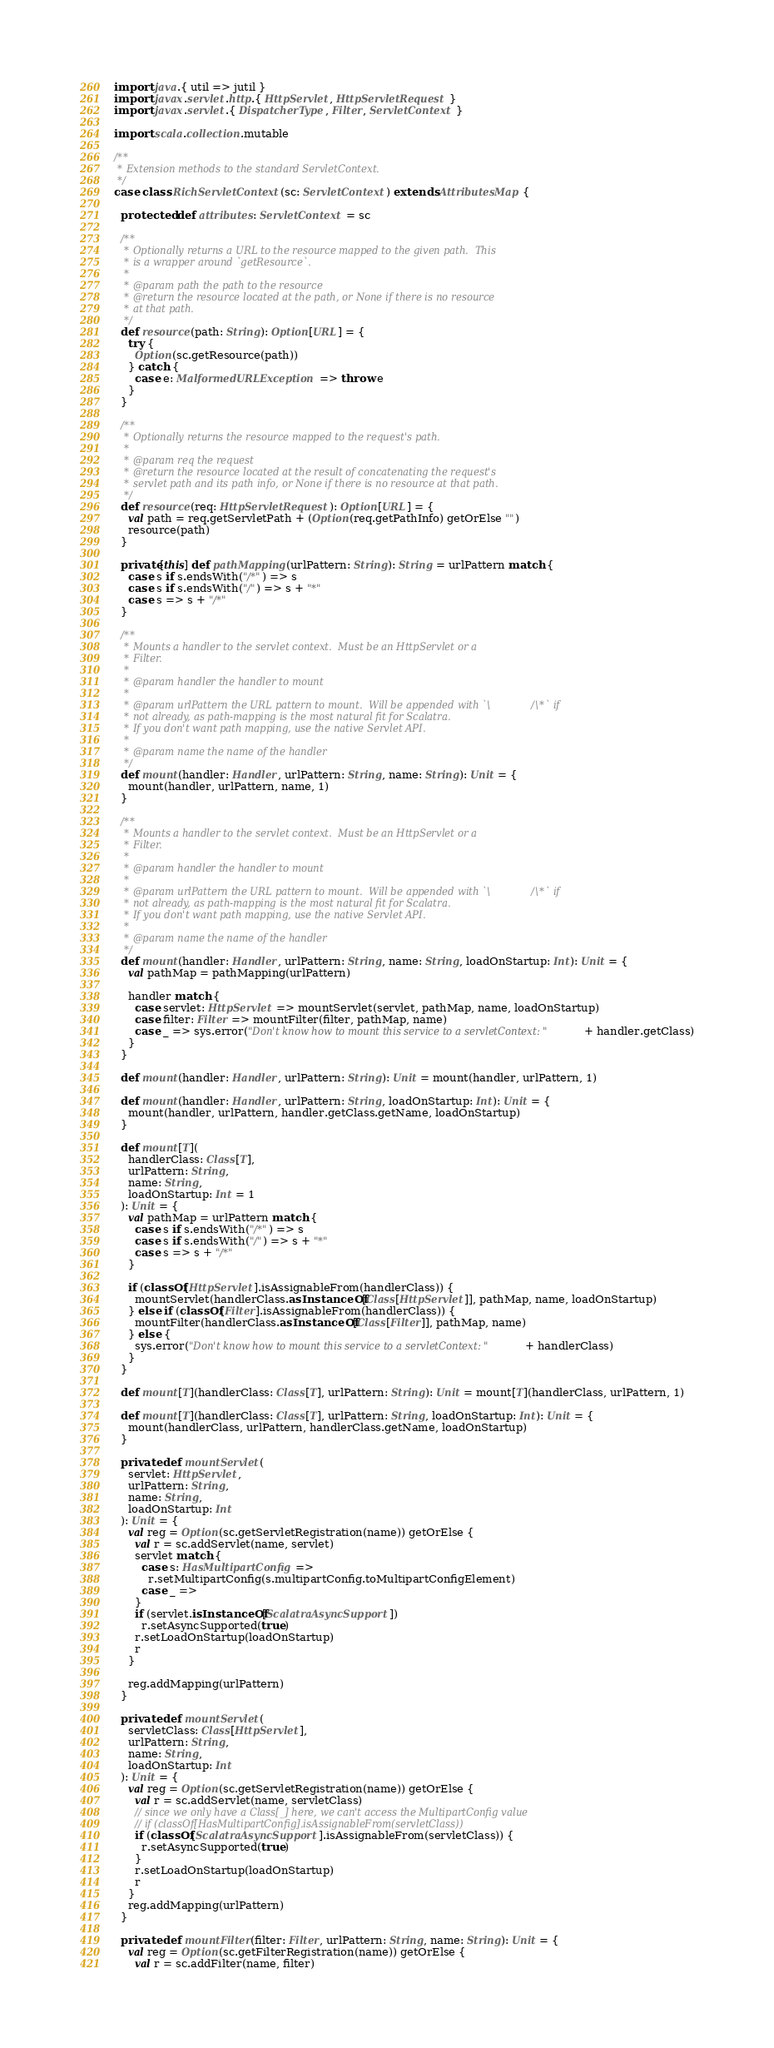Convert code to text. <code><loc_0><loc_0><loc_500><loc_500><_Scala_>import java.{ util => jutil }
import javax.servlet.http.{ HttpServlet, HttpServletRequest }
import javax.servlet.{ DispatcherType, Filter, ServletContext }

import scala.collection.mutable

/**
 * Extension methods to the standard ServletContext.
 */
case class RichServletContext(sc: ServletContext) extends AttributesMap {

  protected def attributes: ServletContext = sc

  /**
   * Optionally returns a URL to the resource mapped to the given path.  This
   * is a wrapper around `getResource`.
   *
   * @param path the path to the resource
   * @return the resource located at the path, or None if there is no resource
   * at that path.
   */
  def resource(path: String): Option[URL] = {
    try {
      Option(sc.getResource(path))
    } catch {
      case e: MalformedURLException => throw e
    }
  }

  /**
   * Optionally returns the resource mapped to the request's path.
   *
   * @param req the request
   * @return the resource located at the result of concatenating the request's
   * servlet path and its path info, or None if there is no resource at that path.
   */
  def resource(req: HttpServletRequest): Option[URL] = {
    val path = req.getServletPath + (Option(req.getPathInfo) getOrElse "")
    resource(path)
  }

  private[this] def pathMapping(urlPattern: String): String = urlPattern match {
    case s if s.endsWith("/*") => s
    case s if s.endsWith("/") => s + "*"
    case s => s + "/*"
  }

  /**
   * Mounts a handler to the servlet context.  Must be an HttpServlet or a
   * Filter.
   *
   * @param handler the handler to mount
   *
   * @param urlPattern the URL pattern to mount.  Will be appended with `\/\*` if
   * not already, as path-mapping is the most natural fit for Scalatra.
   * If you don't want path mapping, use the native Servlet API.
   *
   * @param name the name of the handler
   */
  def mount(handler: Handler, urlPattern: String, name: String): Unit = {
    mount(handler, urlPattern, name, 1)
  }

  /**
   * Mounts a handler to the servlet context.  Must be an HttpServlet or a
   * Filter.
   *
   * @param handler the handler to mount
   *
   * @param urlPattern the URL pattern to mount.  Will be appended with `\/\*` if
   * not already, as path-mapping is the most natural fit for Scalatra.
   * If you don't want path mapping, use the native Servlet API.
   *
   * @param name the name of the handler
   */
  def mount(handler: Handler, urlPattern: String, name: String, loadOnStartup: Int): Unit = {
    val pathMap = pathMapping(urlPattern)

    handler match {
      case servlet: HttpServlet => mountServlet(servlet, pathMap, name, loadOnStartup)
      case filter: Filter => mountFilter(filter, pathMap, name)
      case _ => sys.error("Don't know how to mount this service to a servletContext: " + handler.getClass)
    }
  }

  def mount(handler: Handler, urlPattern: String): Unit = mount(handler, urlPattern, 1)

  def mount(handler: Handler, urlPattern: String, loadOnStartup: Int): Unit = {
    mount(handler, urlPattern, handler.getClass.getName, loadOnStartup)
  }

  def mount[T](
    handlerClass: Class[T],
    urlPattern: String,
    name: String,
    loadOnStartup: Int = 1
  ): Unit = {
    val pathMap = urlPattern match {
      case s if s.endsWith("/*") => s
      case s if s.endsWith("/") => s + "*"
      case s => s + "/*"
    }

    if (classOf[HttpServlet].isAssignableFrom(handlerClass)) {
      mountServlet(handlerClass.asInstanceOf[Class[HttpServlet]], pathMap, name, loadOnStartup)
    } else if (classOf[Filter].isAssignableFrom(handlerClass)) {
      mountFilter(handlerClass.asInstanceOf[Class[Filter]], pathMap, name)
    } else {
      sys.error("Don't know how to mount this service to a servletContext: " + handlerClass)
    }
  }

  def mount[T](handlerClass: Class[T], urlPattern: String): Unit = mount[T](handlerClass, urlPattern, 1)

  def mount[T](handlerClass: Class[T], urlPattern: String, loadOnStartup: Int): Unit = {
    mount(handlerClass, urlPattern, handlerClass.getName, loadOnStartup)
  }

  private def mountServlet(
    servlet: HttpServlet,
    urlPattern: String,
    name: String,
    loadOnStartup: Int
  ): Unit = {
    val reg = Option(sc.getServletRegistration(name)) getOrElse {
      val r = sc.addServlet(name, servlet)
      servlet match {
        case s: HasMultipartConfig =>
          r.setMultipartConfig(s.multipartConfig.toMultipartConfigElement)
        case _ =>
      }
      if (servlet.isInstanceOf[ScalatraAsyncSupport])
        r.setAsyncSupported(true)
      r.setLoadOnStartup(loadOnStartup)
      r
    }

    reg.addMapping(urlPattern)
  }

  private def mountServlet(
    servletClass: Class[HttpServlet],
    urlPattern: String,
    name: String,
    loadOnStartup: Int
  ): Unit = {
    val reg = Option(sc.getServletRegistration(name)) getOrElse {
      val r = sc.addServlet(name, servletClass)
      // since we only have a Class[_] here, we can't access the MultipartConfig value
      // if (classOf[HasMultipartConfig].isAssignableFrom(servletClass))
      if (classOf[ScalatraAsyncSupport].isAssignableFrom(servletClass)) {
        r.setAsyncSupported(true)
      }
      r.setLoadOnStartup(loadOnStartup)
      r
    }
    reg.addMapping(urlPattern)
  }

  private def mountFilter(filter: Filter, urlPattern: String, name: String): Unit = {
    val reg = Option(sc.getFilterRegistration(name)) getOrElse {
      val r = sc.addFilter(name, filter)</code> 